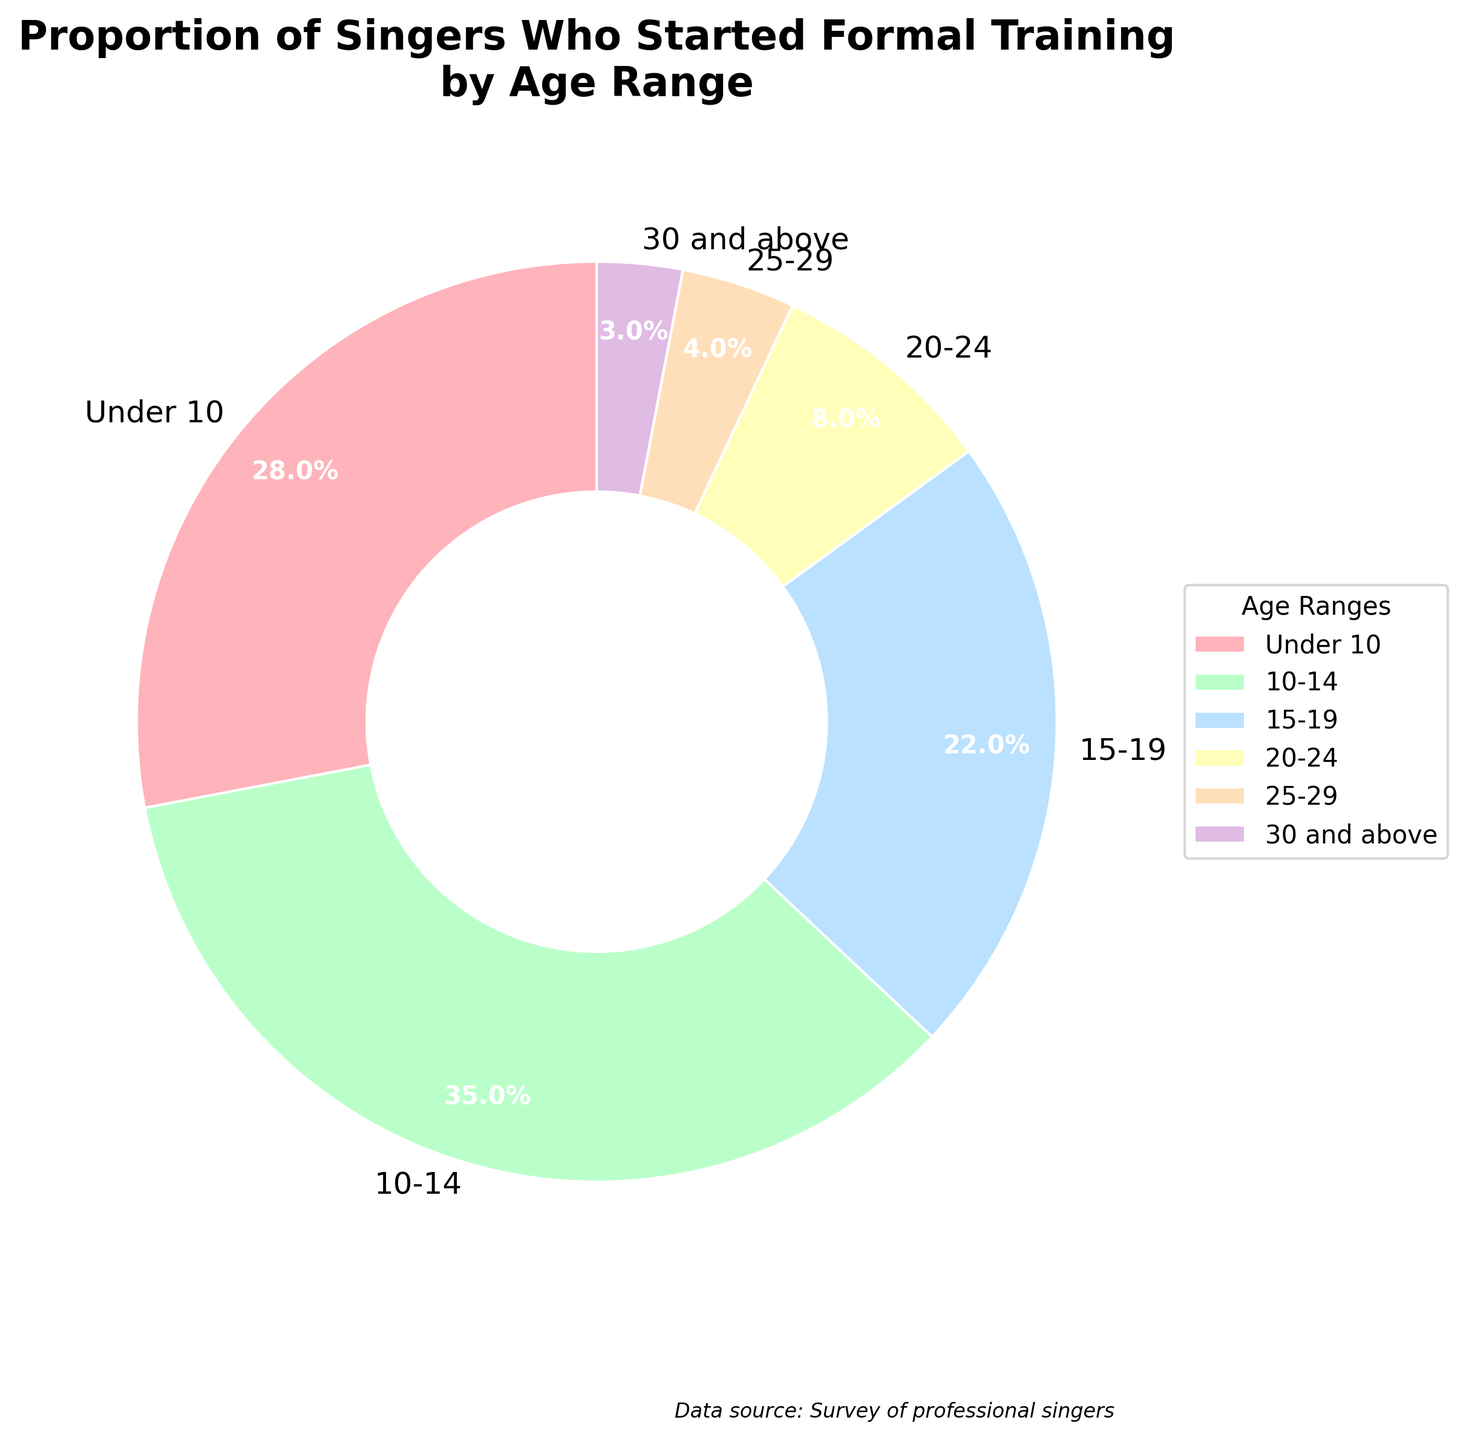Which age range has the highest proportion of singers who started formal training? From the pie chart, the '10-14' age range slice appears the largest, and the label indicates 35%, which is higher than any other age range.
Answer: 10-14 What is the combined percentage of singers who started formal training at ages 20 and above? Adding the percentages for the 20-24, 25-29, and 30 and above age ranges: 8% + 4% + 3% = 15%.
Answer: 15% How does the proportion of singers who started formal training under age 10 compare to those who started at ages 15-19? The pie chart shows 28% for 'Under 10' and 22% for '15-19'. 28% is greater than 22%.
Answer: Greater Which age range has the lowest proportion of singers who started formal training? The '30 and above' age range slice is the smallest, and the label indicates 3%, which is lower than any other age range.
Answer: 30 and above What is the difference in proportion between singers who started formal training at ages 10-14 and those who started at ages 25-29? Subtract the percentage for '25-29' (4%) from '10-14' (35%): 35% - 4% = 31%.
Answer: 31% If you combine the proportions for singers who started training under 10 and those who started at ages 10-14, what percentage of singers does that represent? Adding the percentages for 'Under 10' and '10-14': 28% + 35% = 63%.
Answer: 63% Are more singers starting formal training before the age of 15 or after the age of 15? Combine the percentages for 'Under 10' (28%) and '10-14' (35%) to get singers starting before 15: 28% + 35% = 63%. Combine '15-19' (22%), '20-24' (8%), '25-29' (4%), and '30 and above' (3%) for after 15: 22% + 8% + 4% + 3% = 37%. More singers start before the age of 15.
Answer: Before By how much does the percentage of singers who started training at ages 15-19 exceed those who started at ages 25-29? Subtract the percentage for '25-29' (4%) from '15-19' (22%): 22% - 4% = 18%.
Answer: 18% If we consider the singers starting formal training at ages 10-24, what is the total proportion of singers represented? Adding the percentages for '10-14', '15-19', and '20-24': 35% + 22% + 8% = 65%.
Answer: 65% What is the combined percentage of singers starting formal training in the age ranges with the smallest two proportions? Adding the percentages for '25-29' (4%) and '30 and above' (3%): 4% + 3% = 7%.
Answer: 7% 